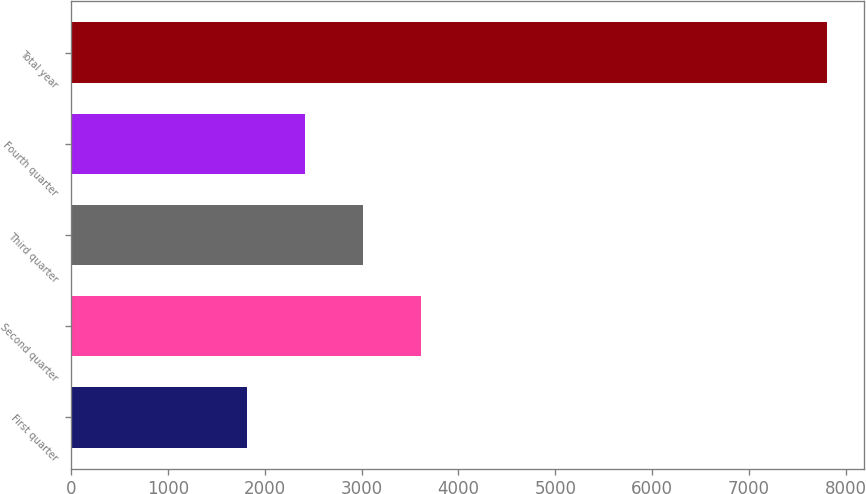<chart> <loc_0><loc_0><loc_500><loc_500><bar_chart><fcel>First quarter<fcel>Second quarter<fcel>Third quarter<fcel>Fourth quarter<fcel>Total year<nl><fcel>1813.1<fcel>3610.19<fcel>3011.16<fcel>2412.13<fcel>7803.4<nl></chart> 